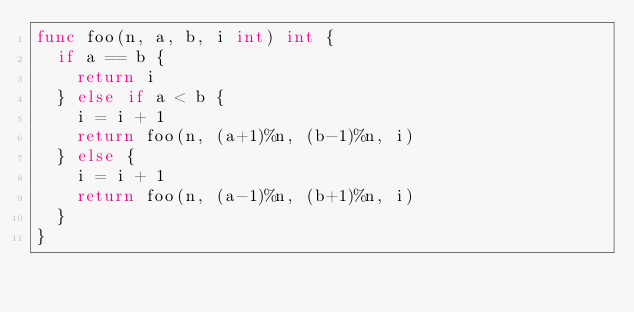<code> <loc_0><loc_0><loc_500><loc_500><_Go_>func foo(n, a, b, i int) int {
  if a == b {
    return i
  } else if a < b {
    i = i + 1
    return foo(n, (a+1)%n, (b-1)%n, i)
  } else {
    i = i + 1
    return foo(n, (a-1)%n, (b+1)%n, i)
  }
}</code> 